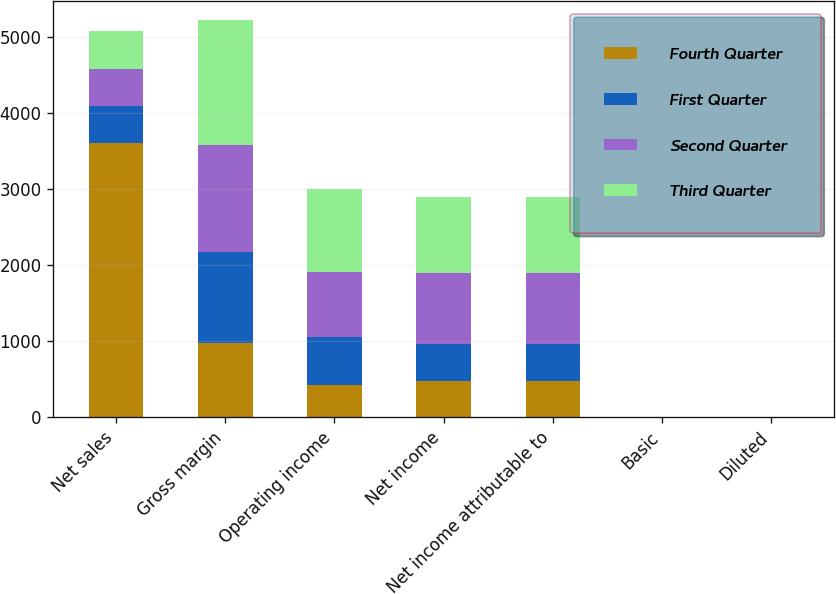Convert chart to OTSL. <chart><loc_0><loc_0><loc_500><loc_500><stacked_bar_chart><ecel><fcel>Net sales<fcel>Gross margin<fcel>Operating income<fcel>Net income<fcel>Net income attributable to<fcel>Basic<fcel>Diluted<nl><fcel>Fourth Quarter<fcel>3600<fcel>970<fcel>427<fcel>471<fcel>471<fcel>0.44<fcel>0.42<nl><fcel>First Quarter<fcel>491<fcel>1202<fcel>631<fcel>491<fcel>491<fcel>0.46<fcel>0.42<nl><fcel>Second Quarter<fcel>491<fcel>1405<fcel>855<fcel>935<fcel>934<fcel>0.87<fcel>0.78<nl><fcel>Third Quarter<fcel>491<fcel>1638<fcel>1085<fcel>1002<fcel>1003<fcel>0.94<fcel>0.84<nl></chart> 